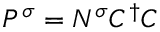Convert formula to latex. <formula><loc_0><loc_0><loc_500><loc_500>P ^ { \sigma } = N ^ { \sigma } C ^ { \dagger } C</formula> 